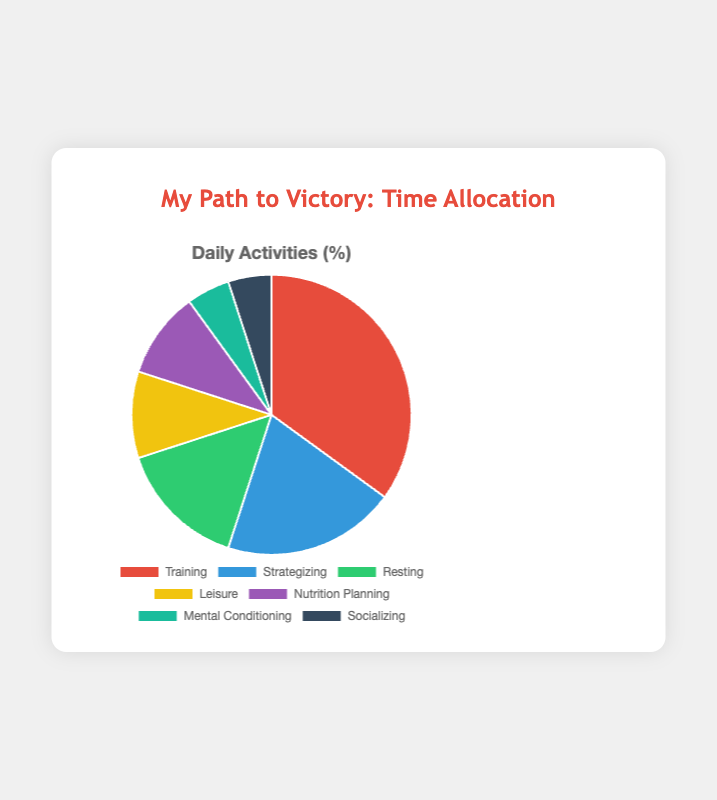What is the percentage of time allocated to Training? The pie chart data shows the percentage of time for each activity. According to the data, Training is allocated 35% of the total time.
Answer: 35% Which activity takes up the most time? By comparing the percentages of all activities in the pie chart, Training has the highest percentage of 35%, which is more than any other activity.
Answer: Training How much more time is spent on Strategizing compared to Socializing? From the pie chart, the percentage of time spent on Strategizing is 20% and on Socializing is 5%. The difference is 20% - 5% = 15%.
Answer: 15% What is the total percentage of time allocated to both Nutrition Planning and Mental Conditioning? Nutrition Planning and Mental Conditioning have allocated percentages of 10% and 5%, respectively. By adding them together, 10% + 5% = 15%.
Answer: 15% Is more time spent on Leisure or Resting? According to the pie chart, Leisure is allocated 10% and Resting is allocated 15%. Therefore, more time is spent on Resting.
Answer: Resting Which activity has the smallest allocation of time? The pie chart shows that the two activities with the smallest allocations are Socializing and Mental Conditioning, both at 5%.
Answer: Socializing or Mental Conditioning Compare the combined time spent on Training and Strategizing versus Resting and Leisure. Which group has more time allocated? The combination of Training (35%) and Strategizing (20%) yields 55%, while Resting (15%) and Leisure (10%) total 25%. Thus, more time is allocated to Training and Strategizing.
Answer: Training and Strategizing What is the combined percentage of time for activities that involve physical effort (Training and Resting)? Training is allocated 35% and Resting is 15%. Combining these, 35% + 15% = 50%.
Answer: 50% Which activities have an equal percentage of time allocation? From the pie chart, both Nutrition Planning and Leisure, as well as Socializing and Mental Conditioning, each have equal allocations of 10% and 5% respectively.
Answer: Nutrition Planning and Leisure; Socializing and Mental Conditioning 